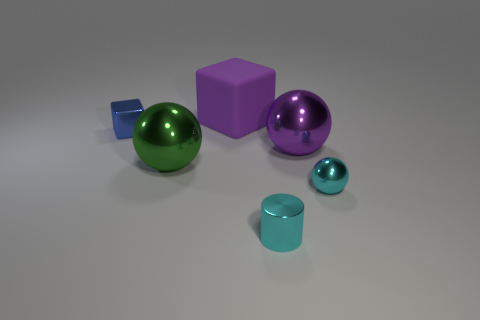Is the block left of the purple rubber thing made of the same material as the big purple block?
Your answer should be compact. No. What is the material of the cyan thing that is the same shape as the green object?
Ensure brevity in your answer.  Metal. What is the material of the tiny blue object?
Offer a terse response. Metal. There is a cyan shiny cylinder that is to the left of the cyan metal sphere; is its size the same as the big purple matte object?
Your response must be concise. No. There is a shiny thing that is in front of the tiny metal sphere; what size is it?
Offer a very short reply. Small. Is there any other thing that has the same material as the large block?
Your response must be concise. No. How many gray cubes are there?
Your answer should be compact. 0. Is the small cylinder the same color as the small metallic ball?
Your answer should be compact. Yes. What color is the shiny object that is both to the right of the green shiny thing and behind the green ball?
Offer a very short reply. Purple. There is a tiny cylinder; are there any shiny objects on the right side of it?
Your answer should be compact. Yes. 